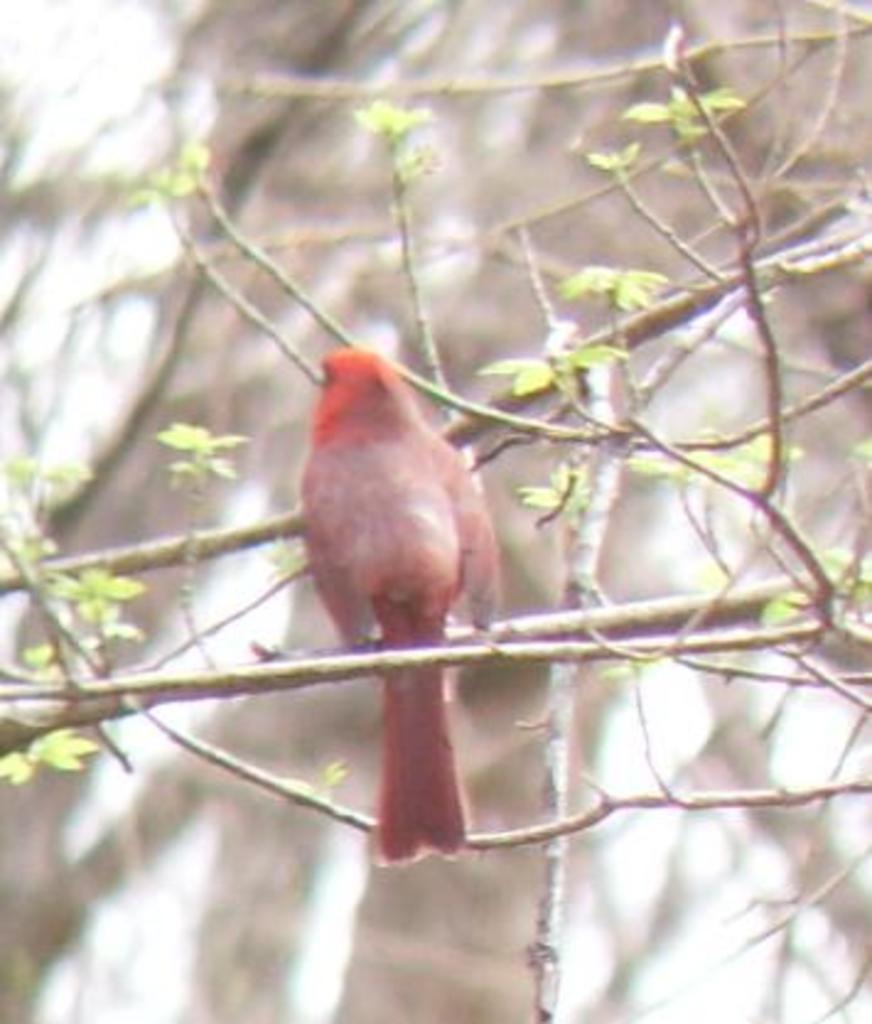Please provide a concise description of this image. In this picture we can see a bird in the middle, on the right side there is a plant, we can see a blurry background. 